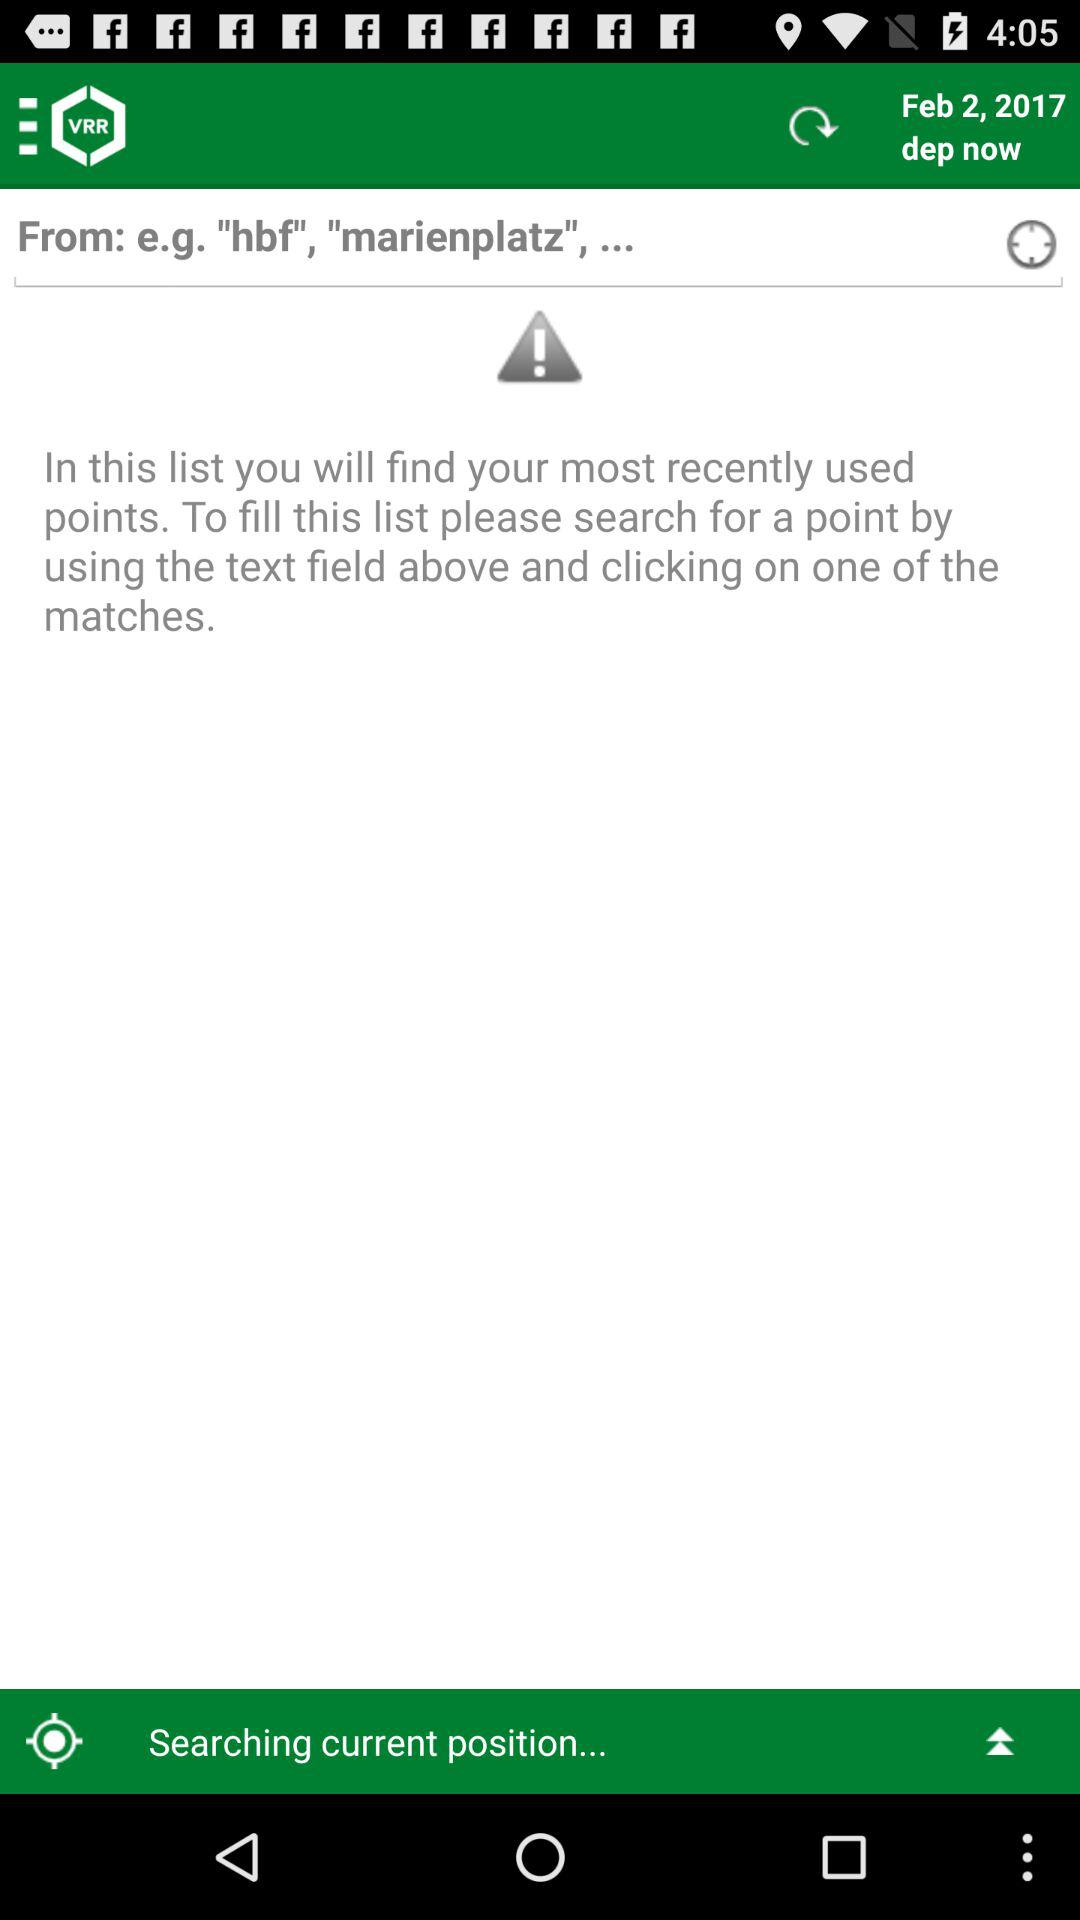What's the date? The date is February 2, 2017. 